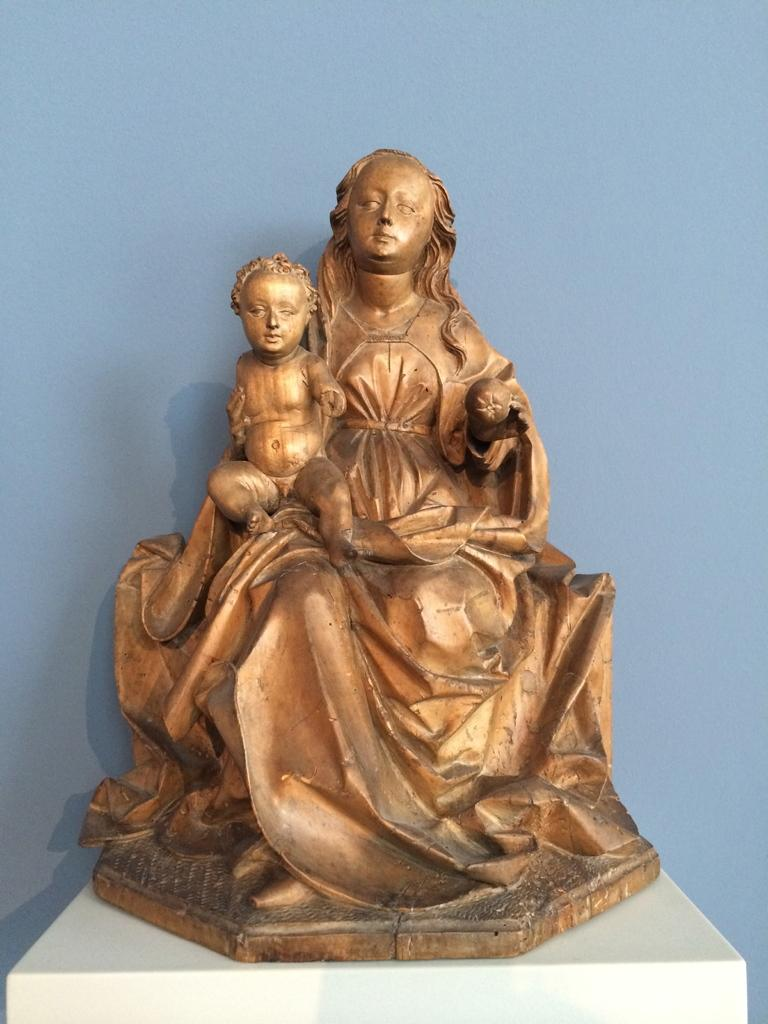What color is the wall in the background of the image? There is a blue wall in the background of the image. What is depicted in the sculpture in the image? The sculpture is of a woman and a baby. Where is the sculpture placed in the image? The sculpture is placed on a pedestal. What is the color of the pedestal? The pedestal is in white color. Is there a cushion placed on the sculpture in the image? No, there is no cushion present in the image. Who is the creator of the sculpture in the image? The creator of the sculpture is not mentioned in the image, so it cannot be determined from the image alone. 